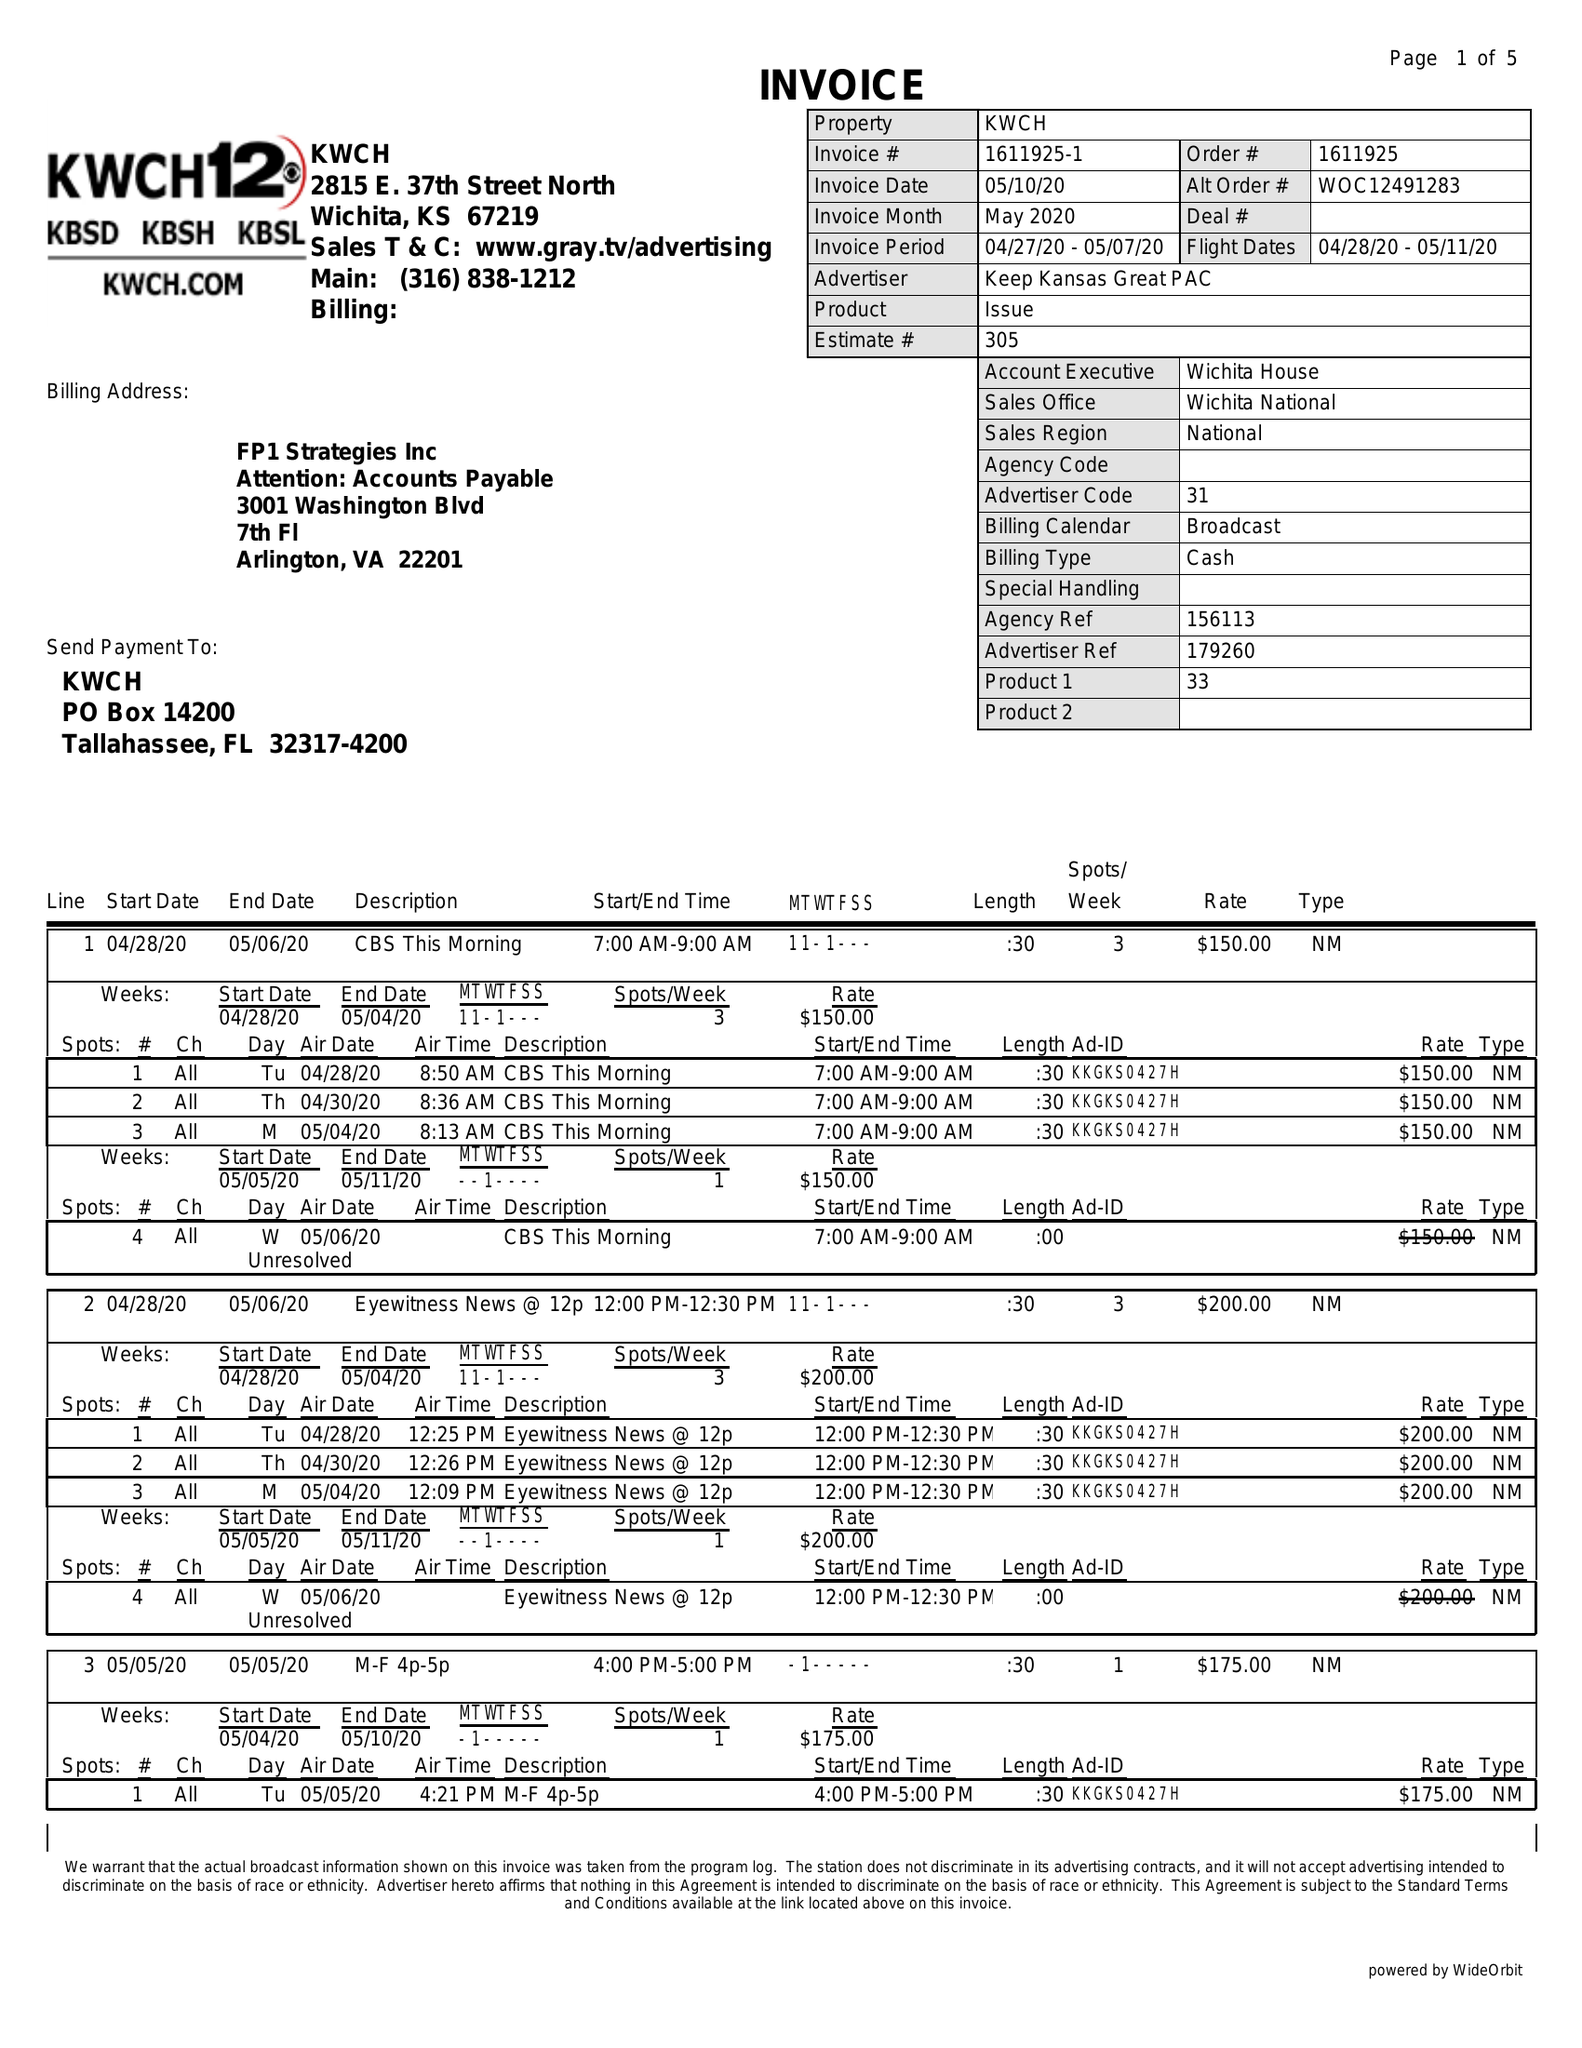What is the value for the flight_to?
Answer the question using a single word or phrase. 05/11/20 